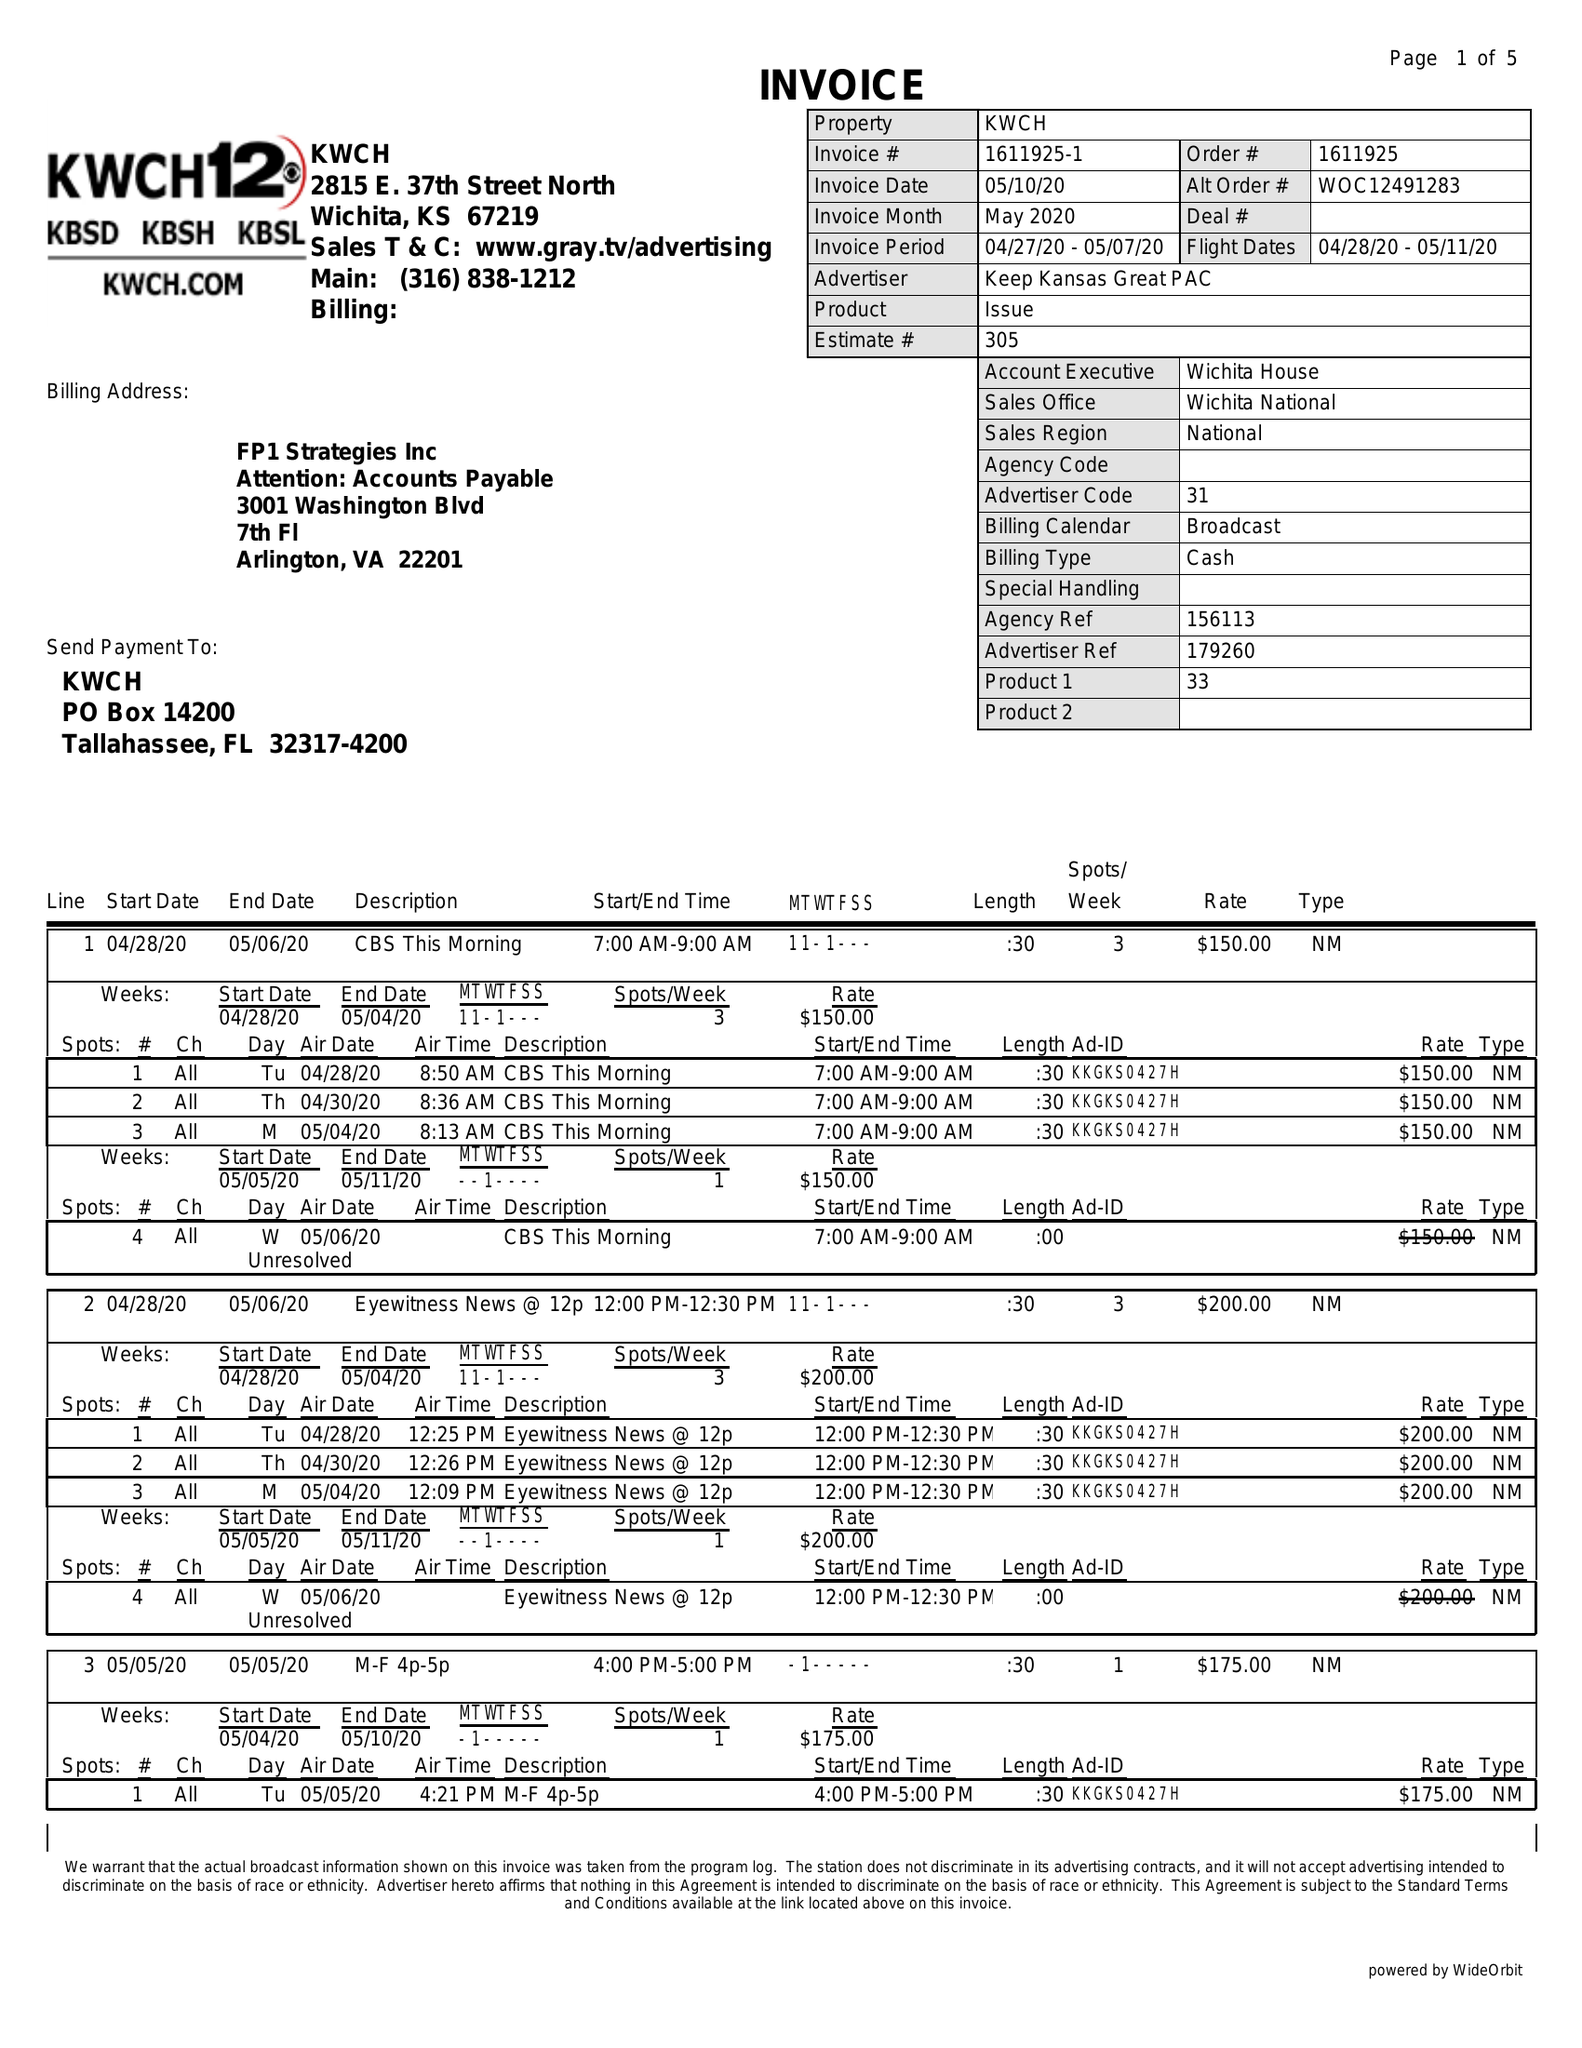What is the value for the flight_to?
Answer the question using a single word or phrase. 05/11/20 